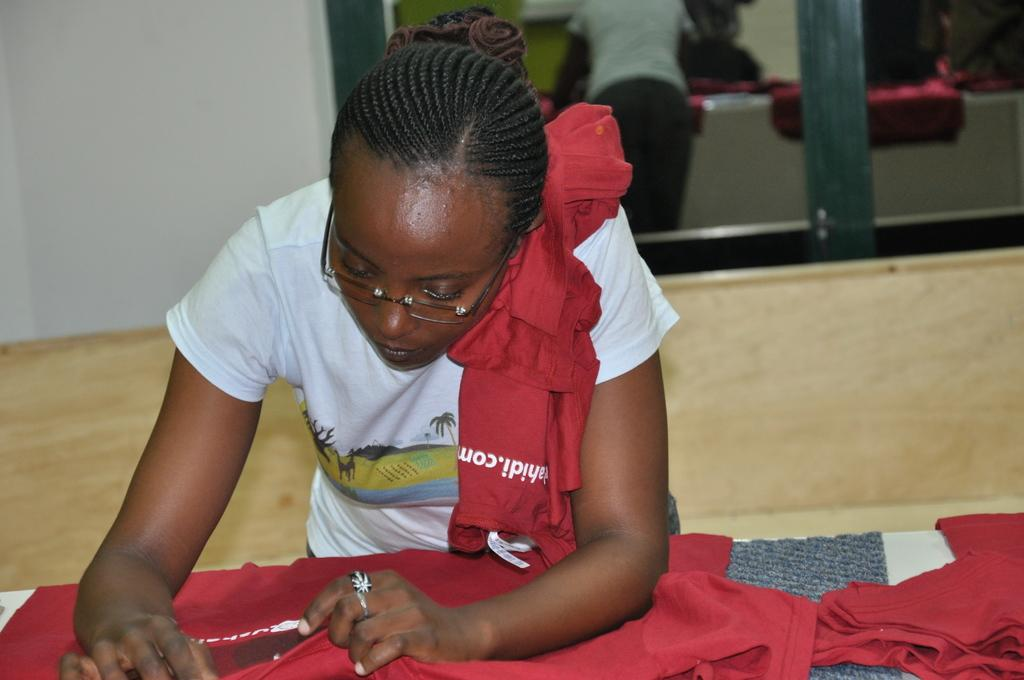What is the main subject of the image? There is a woman in the image. What is the woman doing in the image? The woman is standing in the image. What object is the woman holding? The woman is holding a cloth in the image. What can be seen in the background of the image? There is a window and a wall in the background of the image. Can you describe the reflection in the window? The reflection of the woman is visible in the window. How much advice is the woman giving in the image? There is no indication in the image that the woman is giving advice, so it cannot be determined from the picture. 